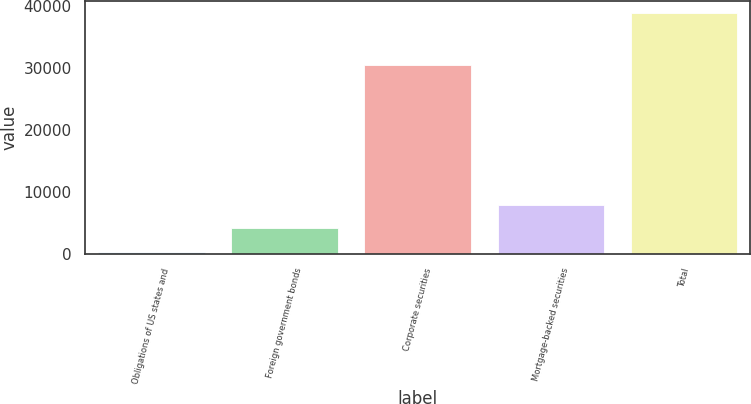Convert chart. <chart><loc_0><loc_0><loc_500><loc_500><bar_chart><fcel>Obligations of US states and<fcel>Foreign government bonds<fcel>Corporate securities<fcel>Mortgage-backed securities<fcel>Total<nl><fcel>224<fcel>4086.4<fcel>30504<fcel>7948.8<fcel>38848<nl></chart> 